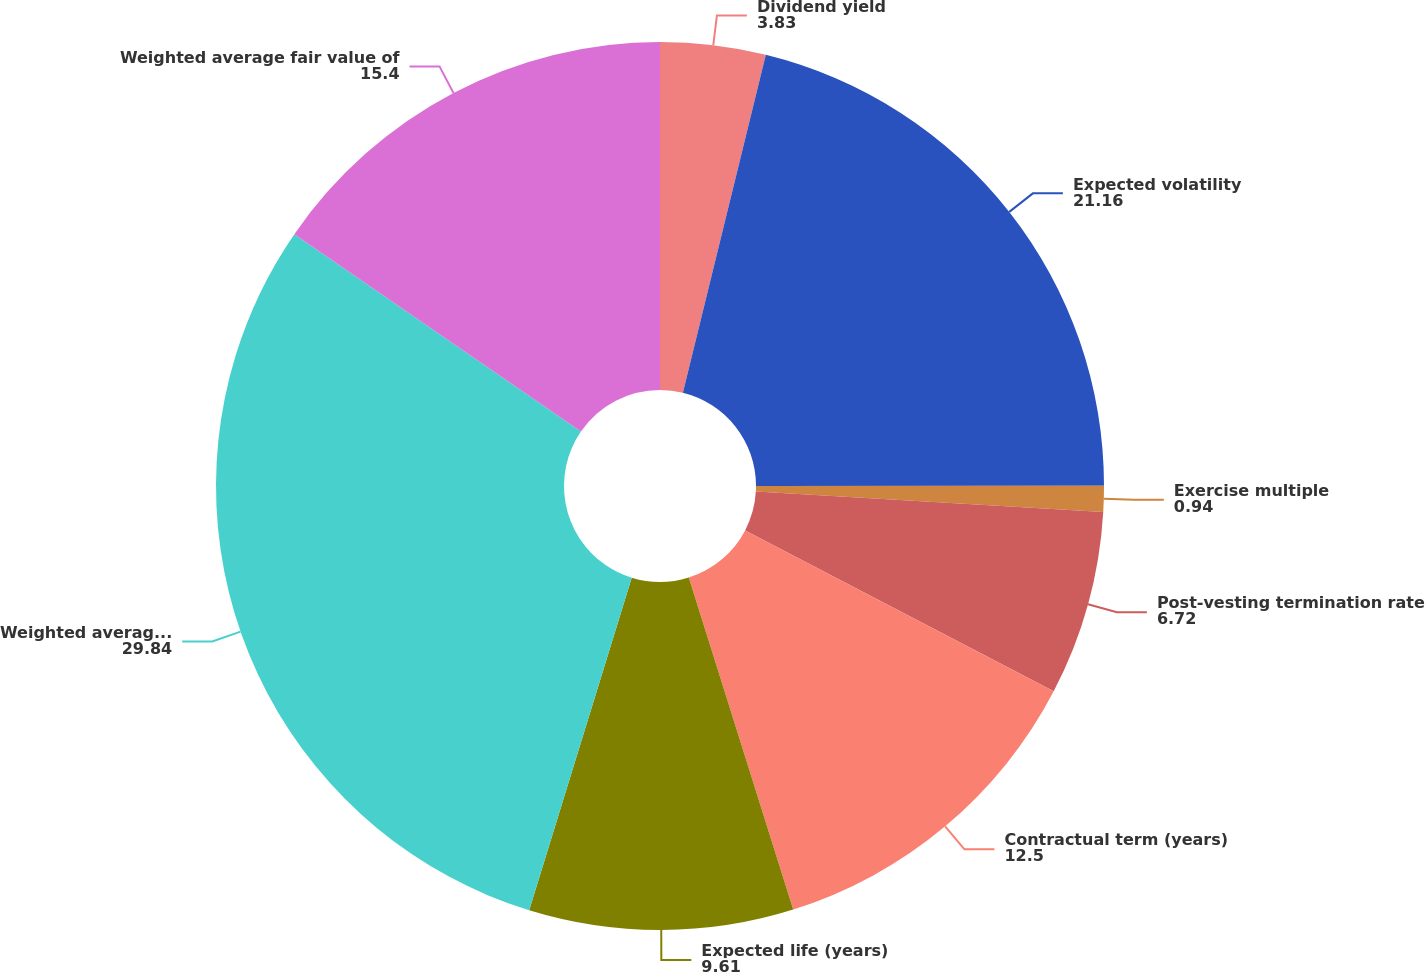<chart> <loc_0><loc_0><loc_500><loc_500><pie_chart><fcel>Dividend yield<fcel>Expected volatility<fcel>Exercise multiple<fcel>Post-vesting termination rate<fcel>Contractual term (years)<fcel>Expected life (years)<fcel>Weighted average exercise<fcel>Weighted average fair value of<nl><fcel>3.83%<fcel>21.16%<fcel>0.94%<fcel>6.72%<fcel>12.5%<fcel>9.61%<fcel>29.84%<fcel>15.4%<nl></chart> 